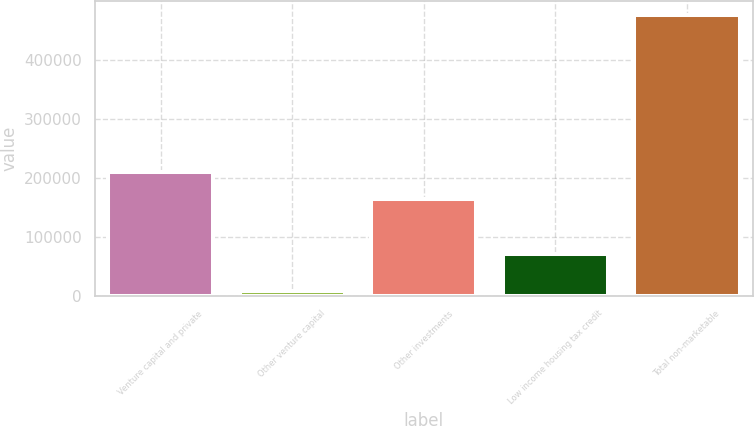Convert chart. <chart><loc_0><loc_0><loc_500><loc_500><bar_chart><fcel>Venture capital and private<fcel>Other venture capital<fcel>Other investments<fcel>Low income housing tax credit<fcel>Total non-marketable<nl><fcel>210462<fcel>8962<fcel>163747<fcel>70318<fcel>476108<nl></chart> 